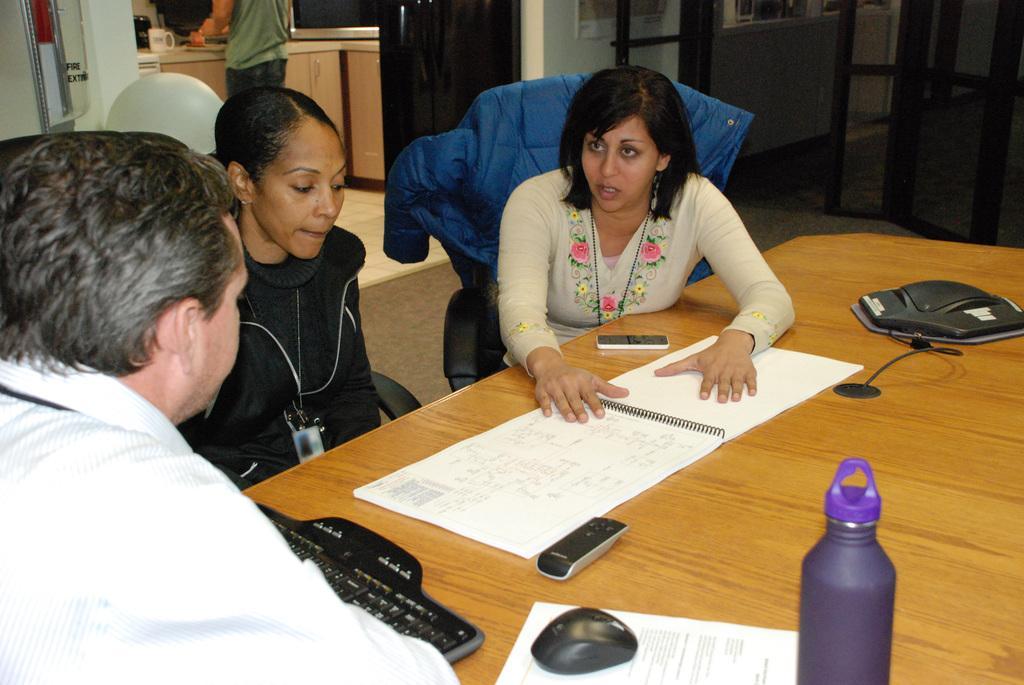Can you describe this image briefly? In the picture we can see two women and men are sitting in the chairs near the table, a woman is explaining something on the paper to a man, On the table we can see a keyboard, mouse, paper, mobile, and bottle. In the background we can see a chair, a person, standing near the desk, and on the desk we can see a cup. 